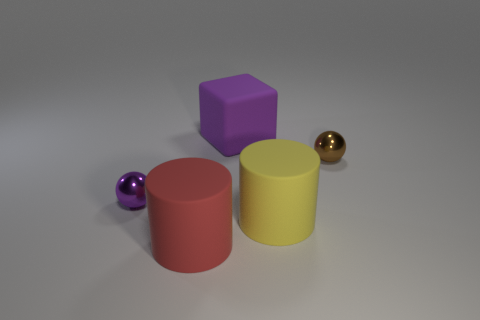Add 3 big purple rubber blocks. How many objects exist? 8 Subtract all spheres. How many objects are left? 3 Subtract 0 green cylinders. How many objects are left? 5 Subtract all big things. Subtract all purple matte cubes. How many objects are left? 1 Add 1 purple blocks. How many purple blocks are left? 2 Add 2 large purple metallic cubes. How many large purple metallic cubes exist? 2 